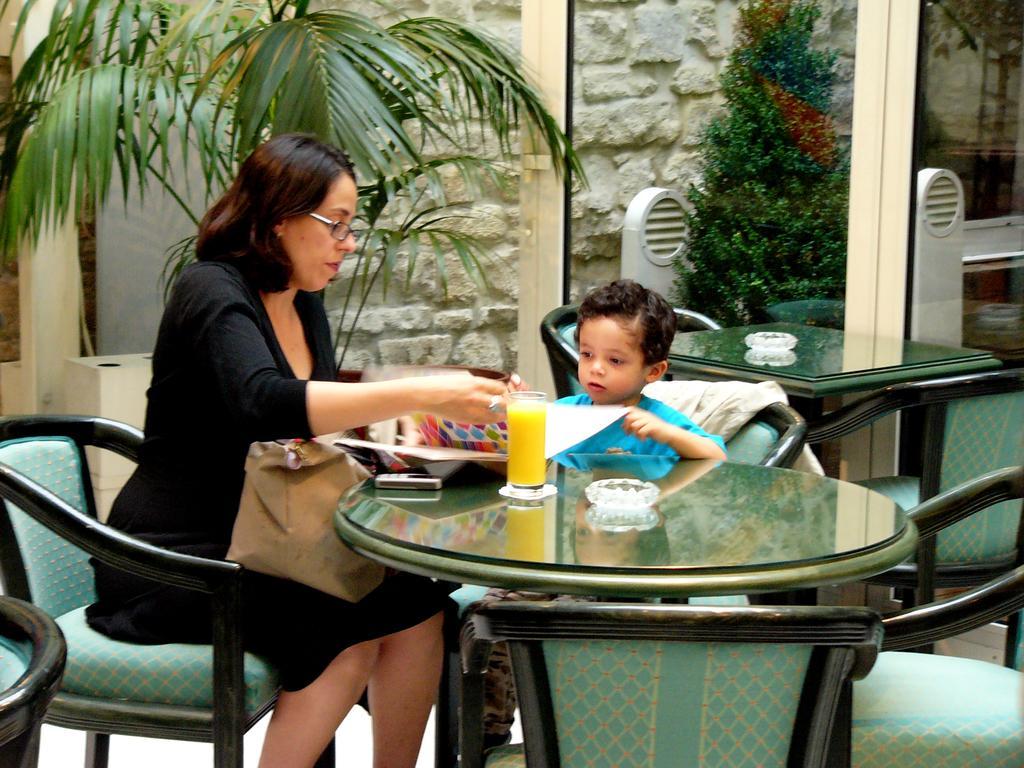Can you describe this image briefly? In this image we can see a woman sitting on a chair and she is on the left side. There is a boy sitting on a chair. This is a glass table where a glass of juice and mobile phone are kept on it. Here we can see trees and a glass door. 